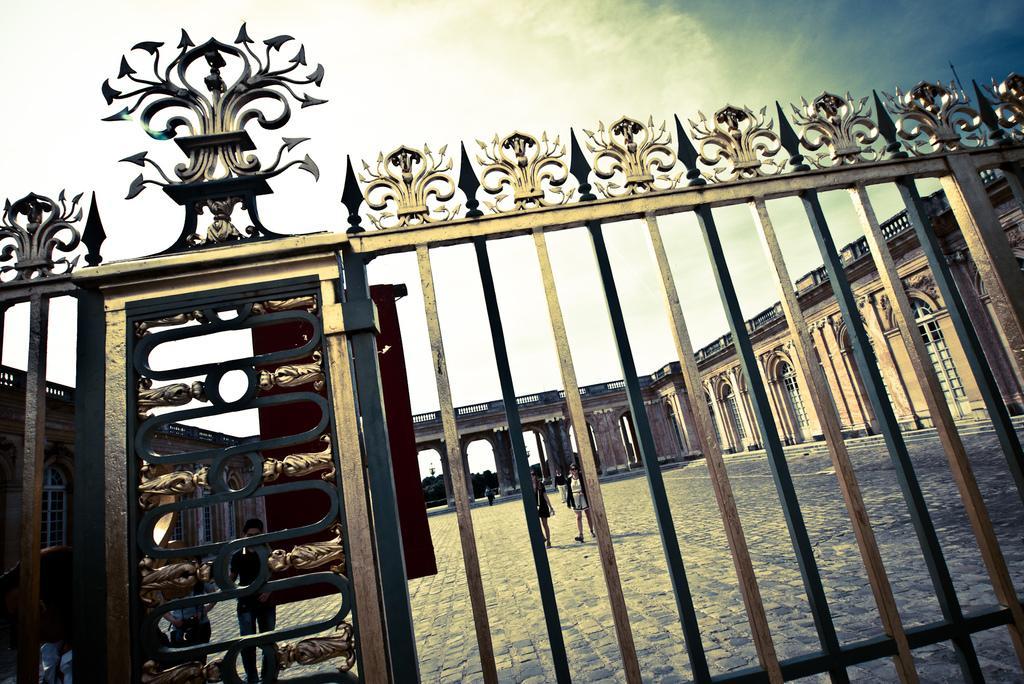Can you describe this image briefly? Here we can see a fence. Sky is cloudy. Backside of this fence we can see wall, windows, doors and people. This is bridge. 